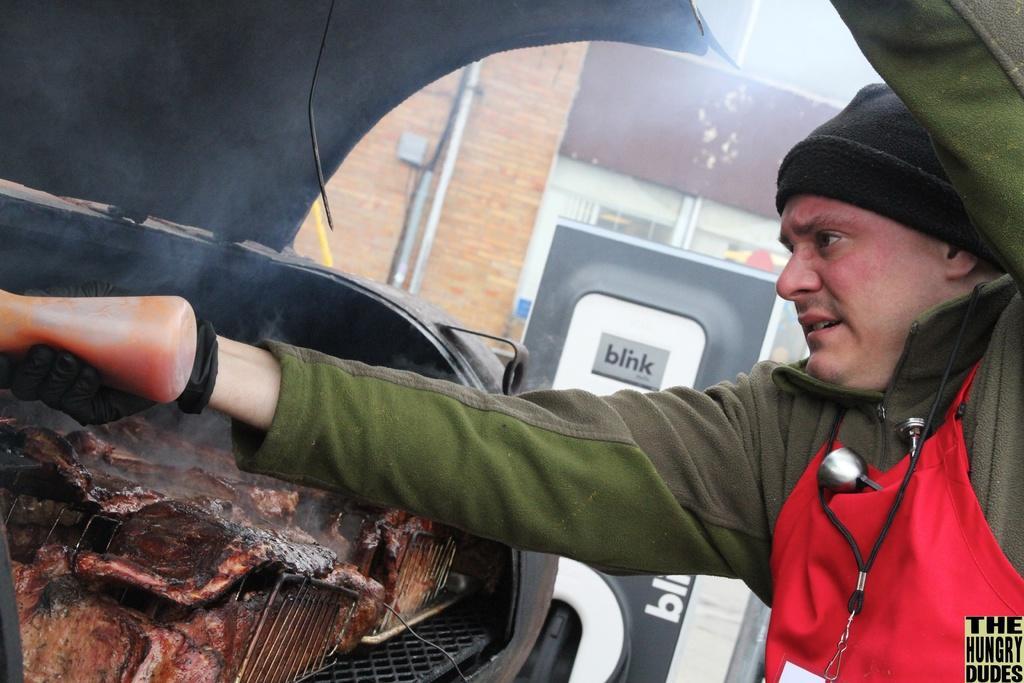How would you summarize this image in a sentence or two? In this image we can see a person holding the sauce bottle. We can also see the meat on the grill. In the background there is a building, board with text and also plastic tubes. In the bottom right corner there is text. 